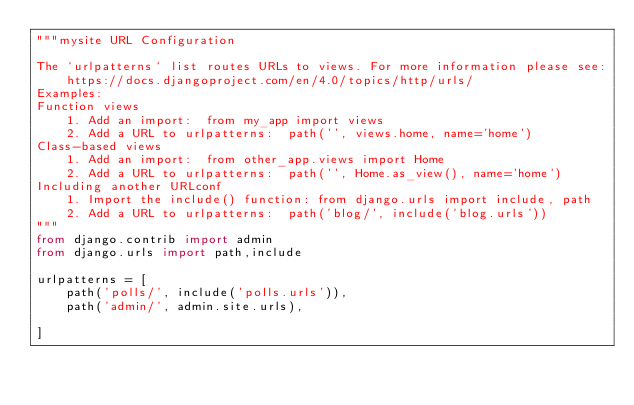Convert code to text. <code><loc_0><loc_0><loc_500><loc_500><_Python_>"""mysite URL Configuration

The `urlpatterns` list routes URLs to views. For more information please see:
    https://docs.djangoproject.com/en/4.0/topics/http/urls/
Examples:
Function views
    1. Add an import:  from my_app import views
    2. Add a URL to urlpatterns:  path('', views.home, name='home')
Class-based views
    1. Add an import:  from other_app.views import Home
    2. Add a URL to urlpatterns:  path('', Home.as_view(), name='home')
Including another URLconf
    1. Import the include() function: from django.urls import include, path
    2. Add a URL to urlpatterns:  path('blog/', include('blog.urls'))
"""
from django.contrib import admin
from django.urls import path,include

urlpatterns = [
    path('polls/', include('polls.urls')),
    path('admin/', admin.site.urls),
    
]
</code> 